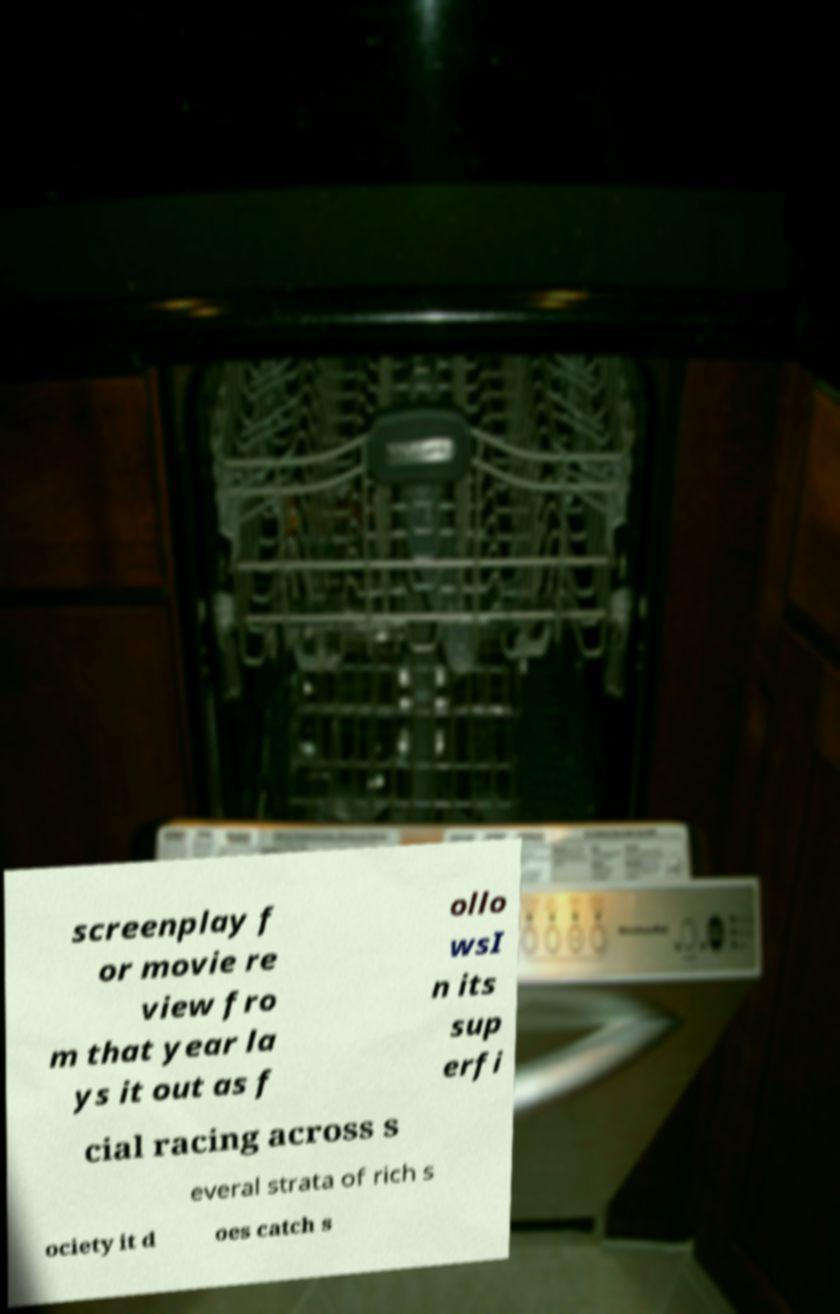What messages or text are displayed in this image? I need them in a readable, typed format. screenplay f or movie re view fro m that year la ys it out as f ollo wsI n its sup erfi cial racing across s everal strata of rich s ociety it d oes catch s 